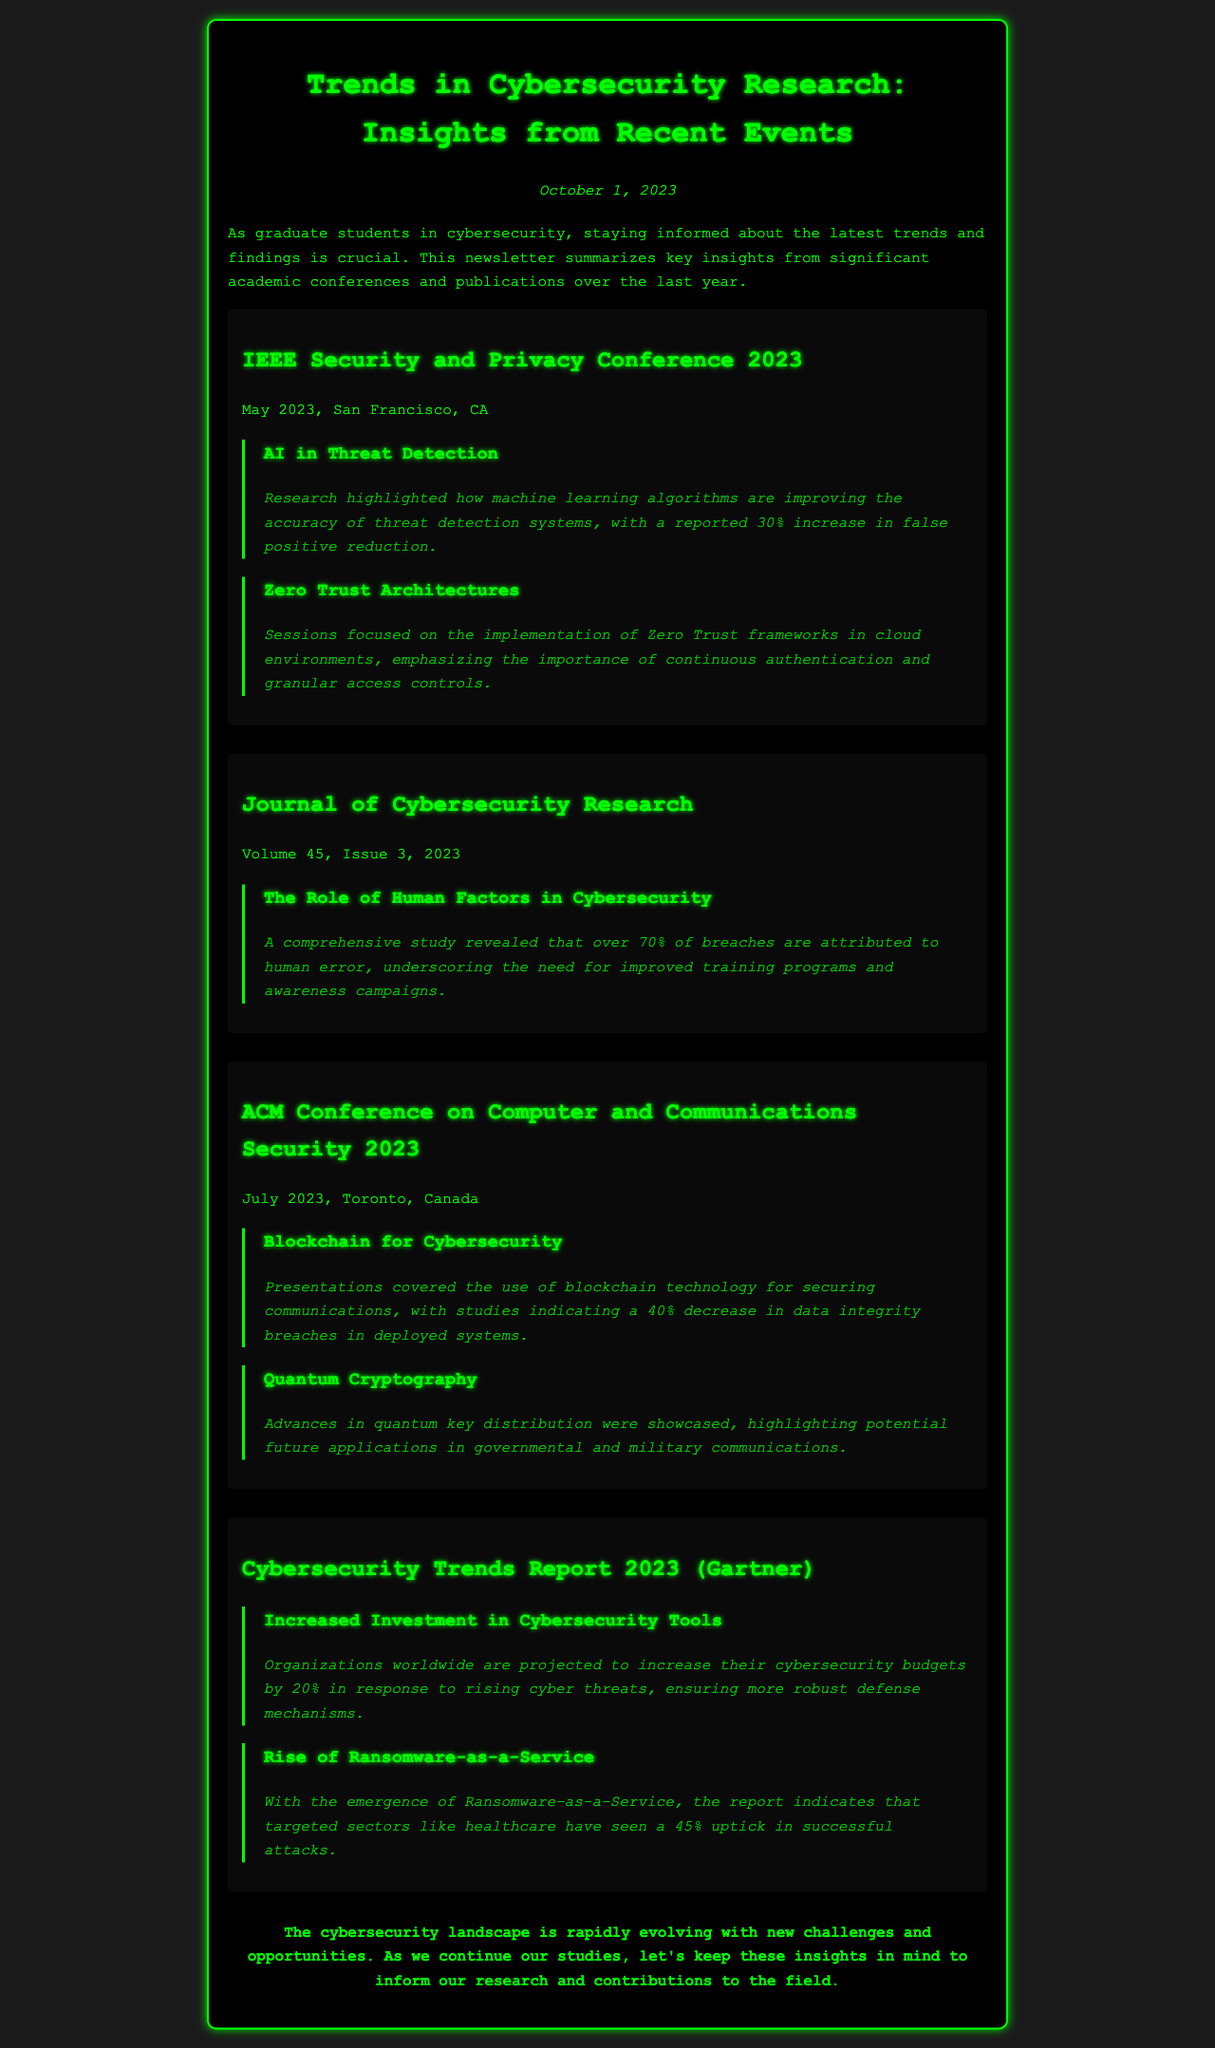What was highlighted in the IEEE Security and Privacy Conference 2023 about AI? The document notes that research highlighted how machine learning algorithms are improving the accuracy of threat detection systems, with a reported 30% increase in false positive reduction.
Answer: AI in Threat Detection What percentage of breaches are attributed to human error according to the Journal of Cybersecurity Research? The document states that a comprehensive study revealed that over 70% of breaches are attributed to human error.
Answer: 70% What framework is emphasized in the sessions of the IEEE Security and Privacy Conference? The document mentions that sessions focused on the implementation of Zero Trust frameworks in cloud environments.
Answer: Zero Trust Architectures In which city was the ACM Conference on Computer and Communications Security 2023 held? The document indicates that the conference was held in Toronto, Canada.
Answer: Toronto What is the projected increase in cybersecurity budgets according to the Cybersecurity Trends Report 2023? The report states that organizations worldwide are projected to increase their cybersecurity budgets by 20%.
Answer: 20% 